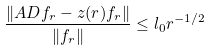<formula> <loc_0><loc_0><loc_500><loc_500>\frac { \| A D f _ { r } - z ( r ) f _ { r } \| } { \| f _ { r } \| } \leq l _ { 0 } r ^ { - 1 / 2 }</formula> 